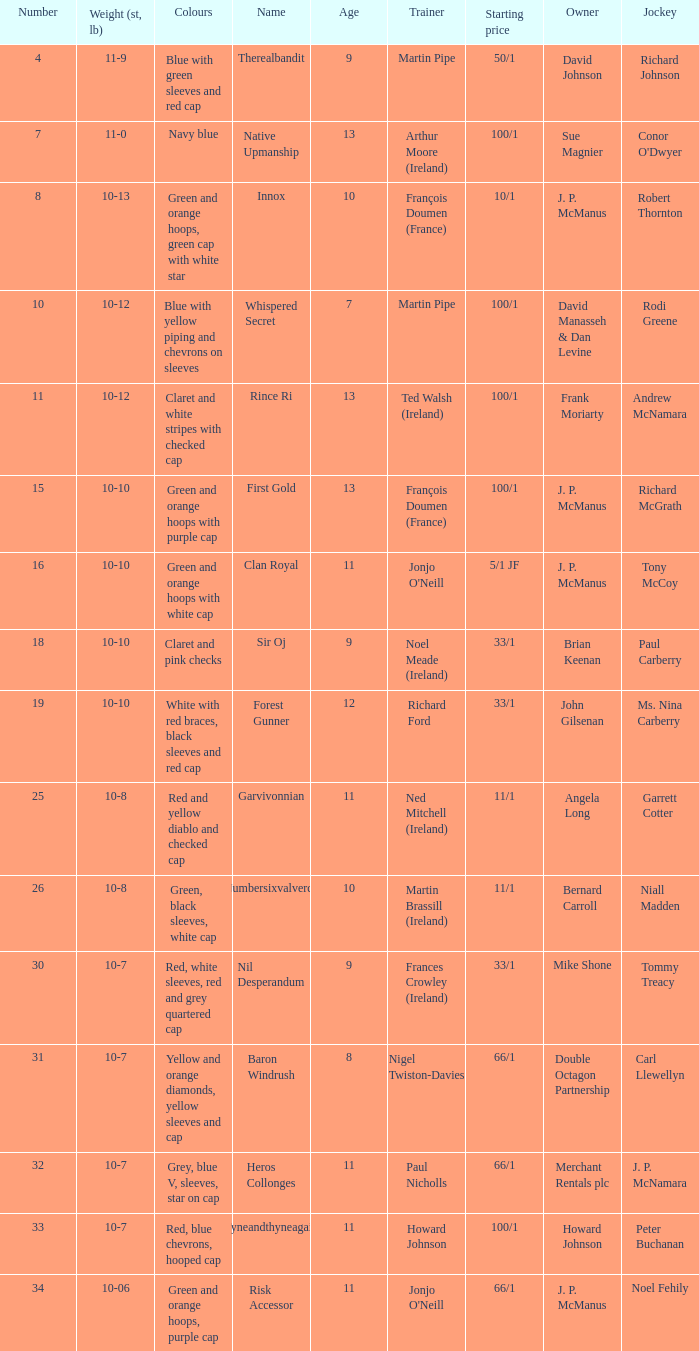What was the name that had a starting price of 11/1 and a jockey named Garrett Cotter? Garvivonnian. 